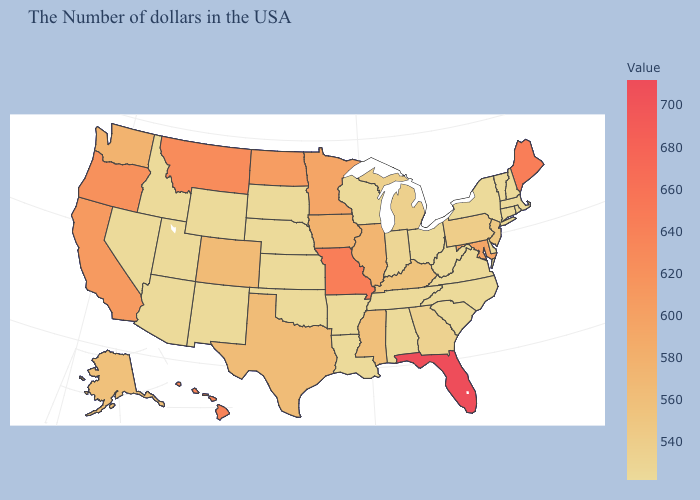Among the states that border Florida , which have the highest value?
Keep it brief. Georgia. Among the states that border Indiana , does Michigan have the highest value?
Be succinct. No. Does Maine have the highest value in the Northeast?
Short answer required. Yes. Which states have the lowest value in the USA?
Answer briefly. Massachusetts, Rhode Island, New Hampshire, Vermont, Connecticut, New York, Delaware, Virginia, North Carolina, South Carolina, West Virginia, Ohio, Alabama, Tennessee, Wisconsin, Louisiana, Arkansas, Kansas, Nebraska, Oklahoma, South Dakota, Wyoming, New Mexico, Utah, Arizona, Idaho, Nevada. 